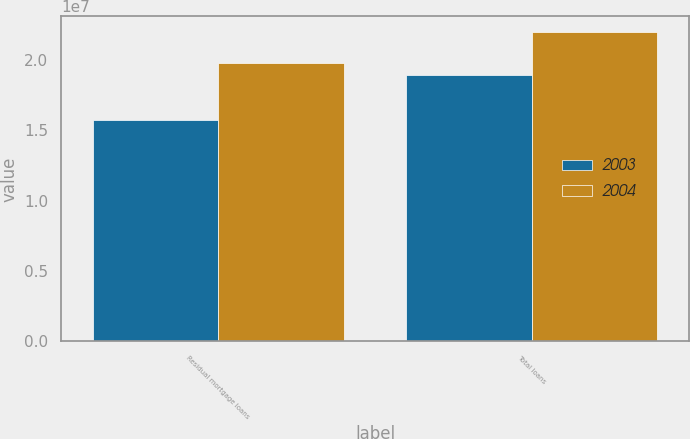<chart> <loc_0><loc_0><loc_500><loc_500><stacked_bar_chart><ecel><fcel>Residual mortgage loans<fcel>Total loans<nl><fcel>2003<fcel>1.5733e+07<fcel>1.89771e+07<nl><fcel>2004<fcel>1.98356e+07<fcel>2.20219e+07<nl></chart> 